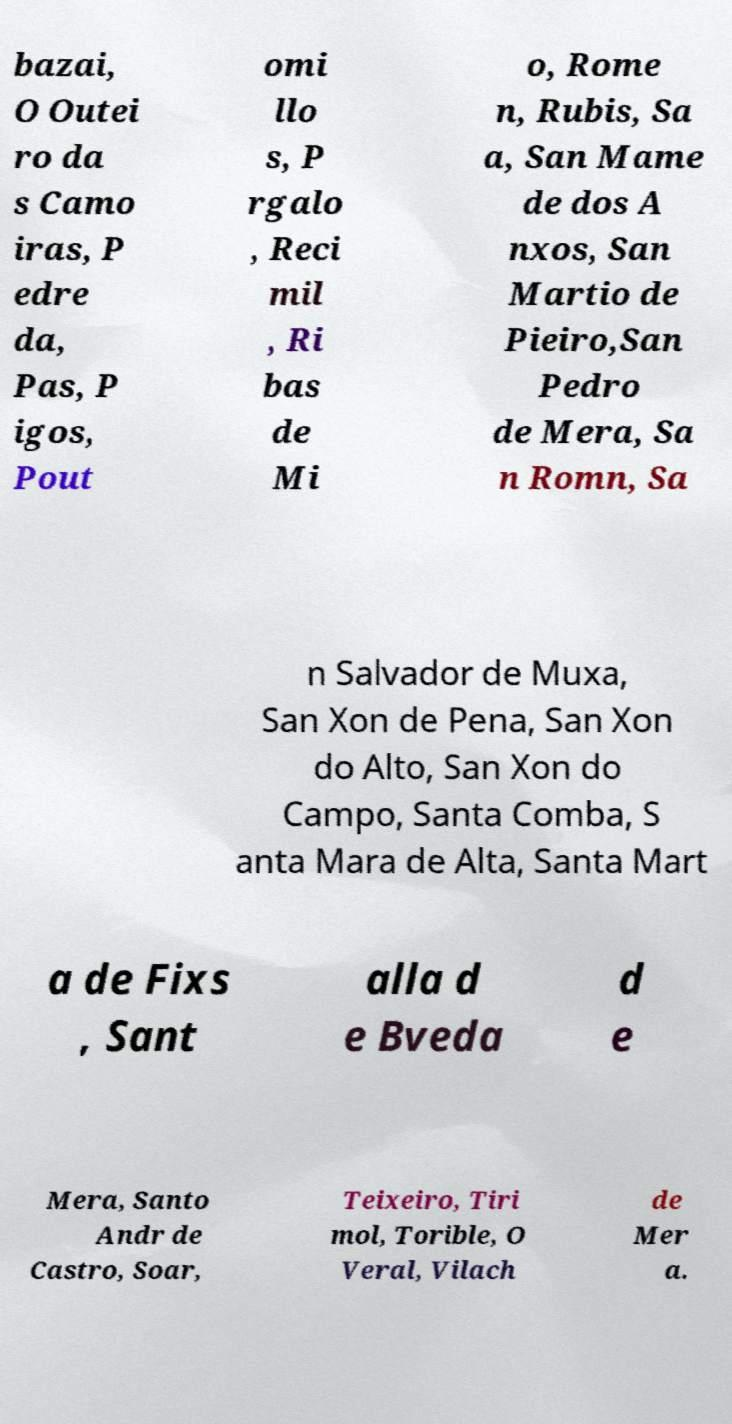For documentation purposes, I need the text within this image transcribed. Could you provide that? bazai, O Outei ro da s Camo iras, P edre da, Pas, P igos, Pout omi llo s, P rgalo , Reci mil , Ri bas de Mi o, Rome n, Rubis, Sa a, San Mame de dos A nxos, San Martio de Pieiro,San Pedro de Mera, Sa n Romn, Sa n Salvador de Muxa, San Xon de Pena, San Xon do Alto, San Xon do Campo, Santa Comba, S anta Mara de Alta, Santa Mart a de Fixs , Sant alla d e Bveda d e Mera, Santo Andr de Castro, Soar, Teixeiro, Tiri mol, Torible, O Veral, Vilach de Mer a. 